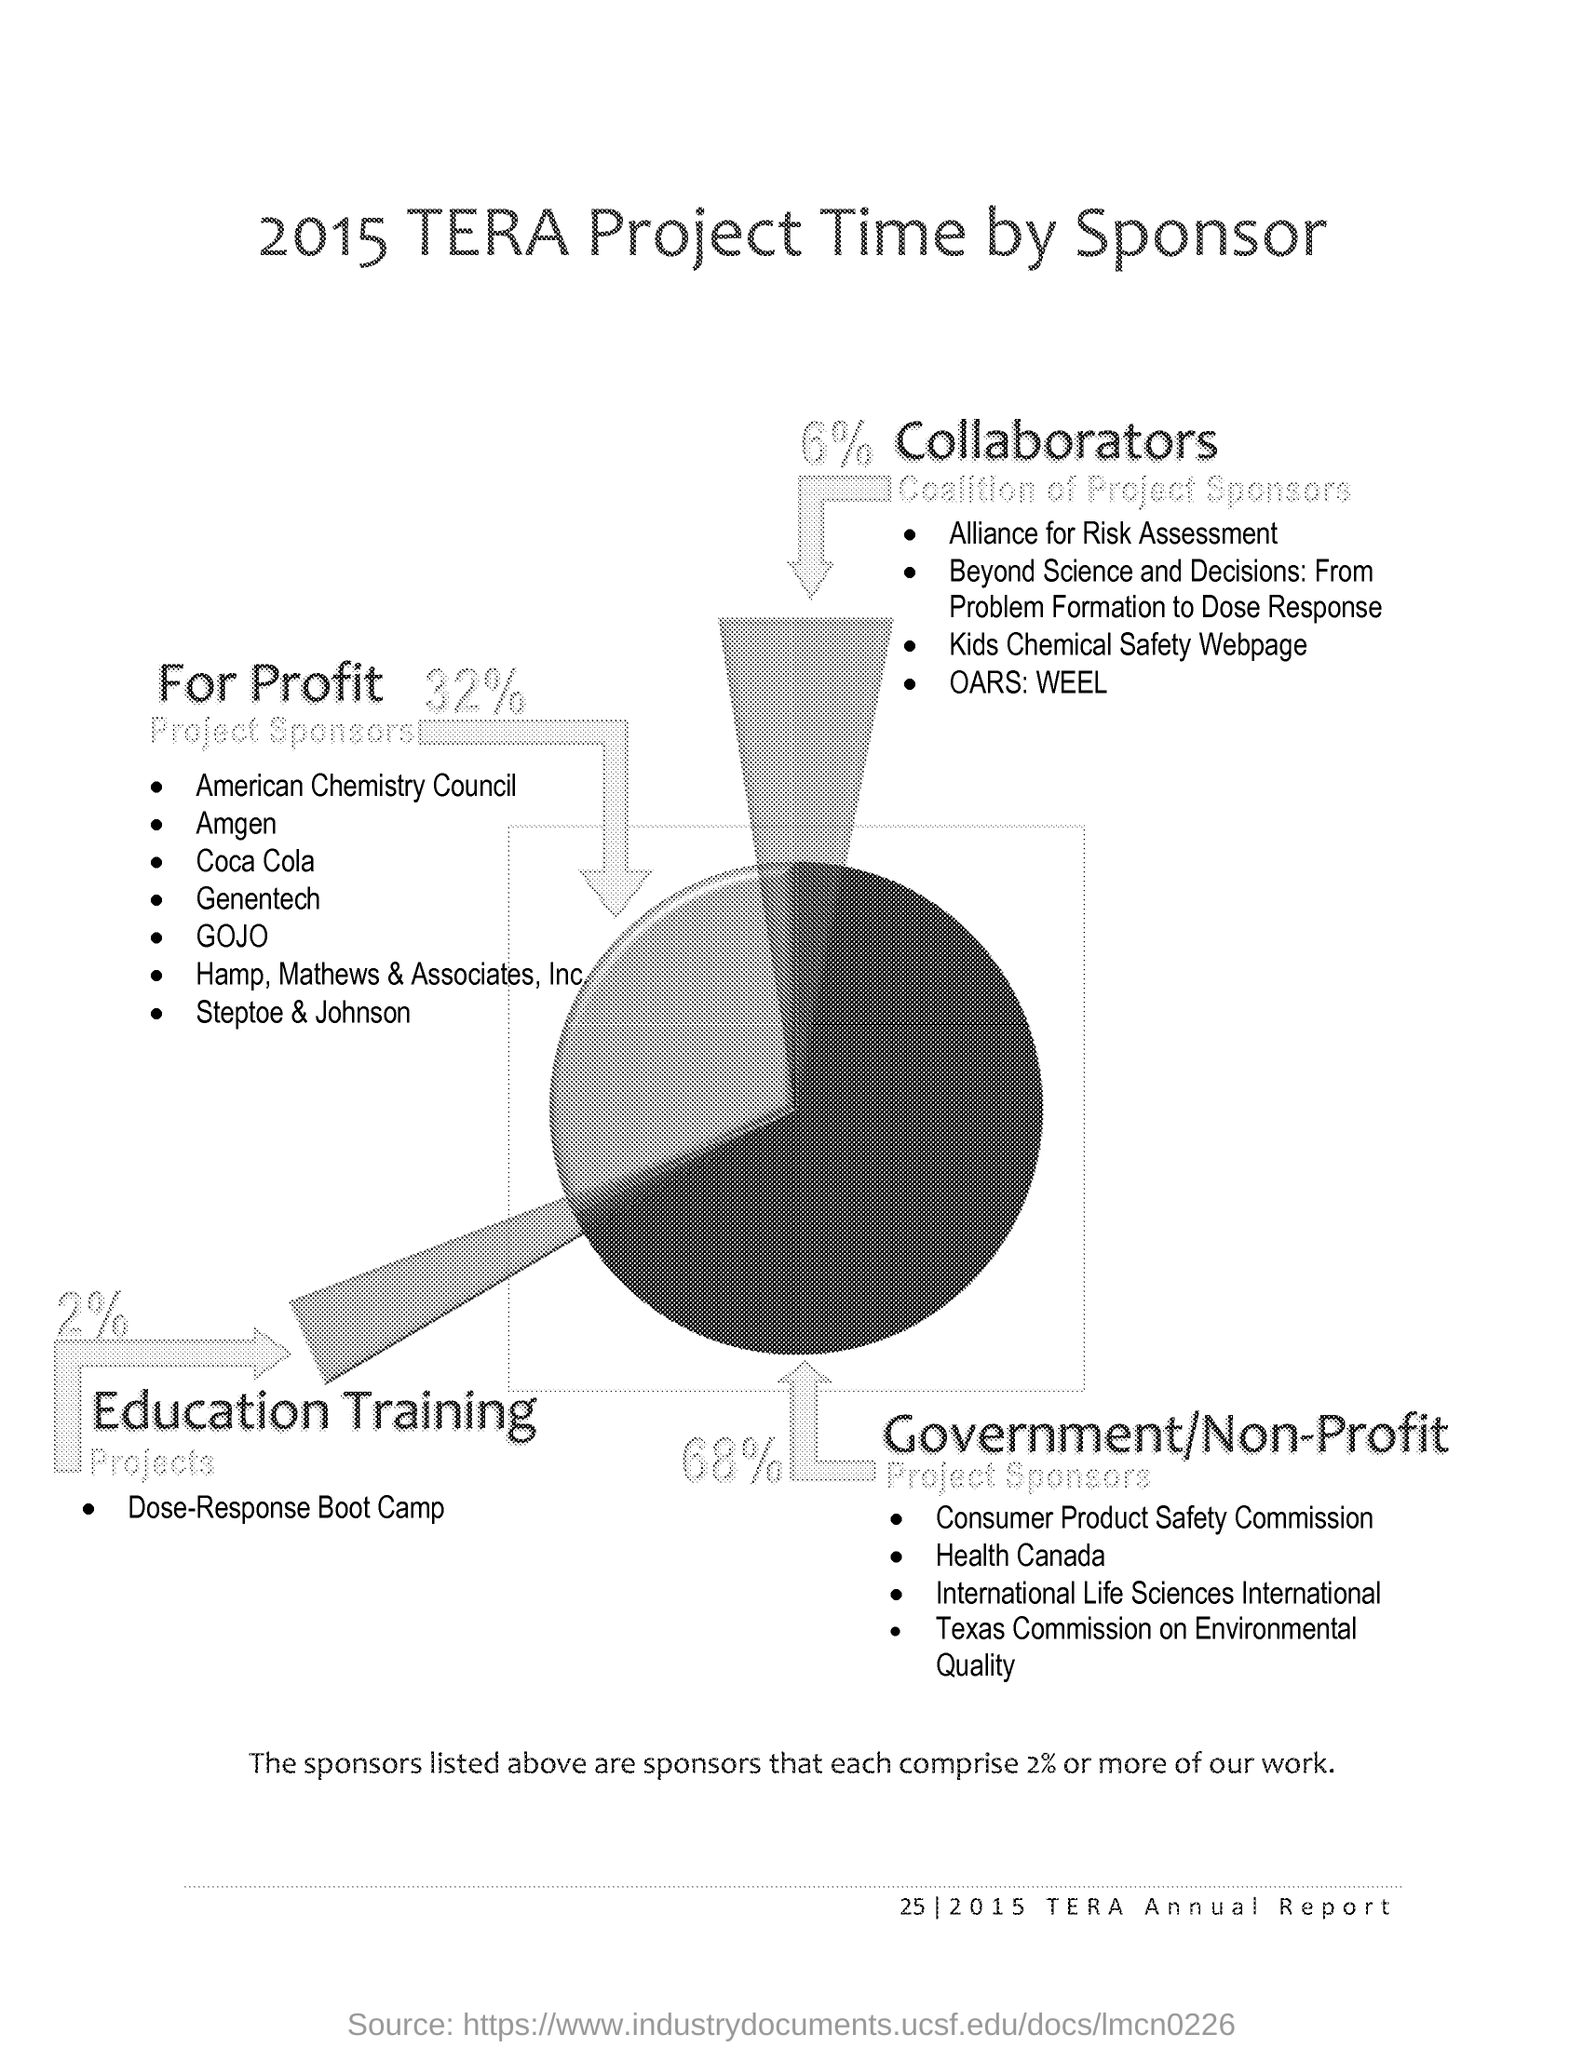Draw attention to some important aspects in this diagram. According to the data, 32% of project sponsors in the analysis were from for-profit organizations. The sponsors listed comprise at least 2% of the total work. Coca Cola is classified as a FOR PROFIT sponsor. The American Chemistry Council is the first for-profit sponsor that has been listed. According to the data, 68% of project sponsors for Government/Non-Profit organizations were identified. 